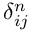Convert formula to latex. <formula><loc_0><loc_0><loc_500><loc_500>\delta _ { i j } ^ { n }</formula> 